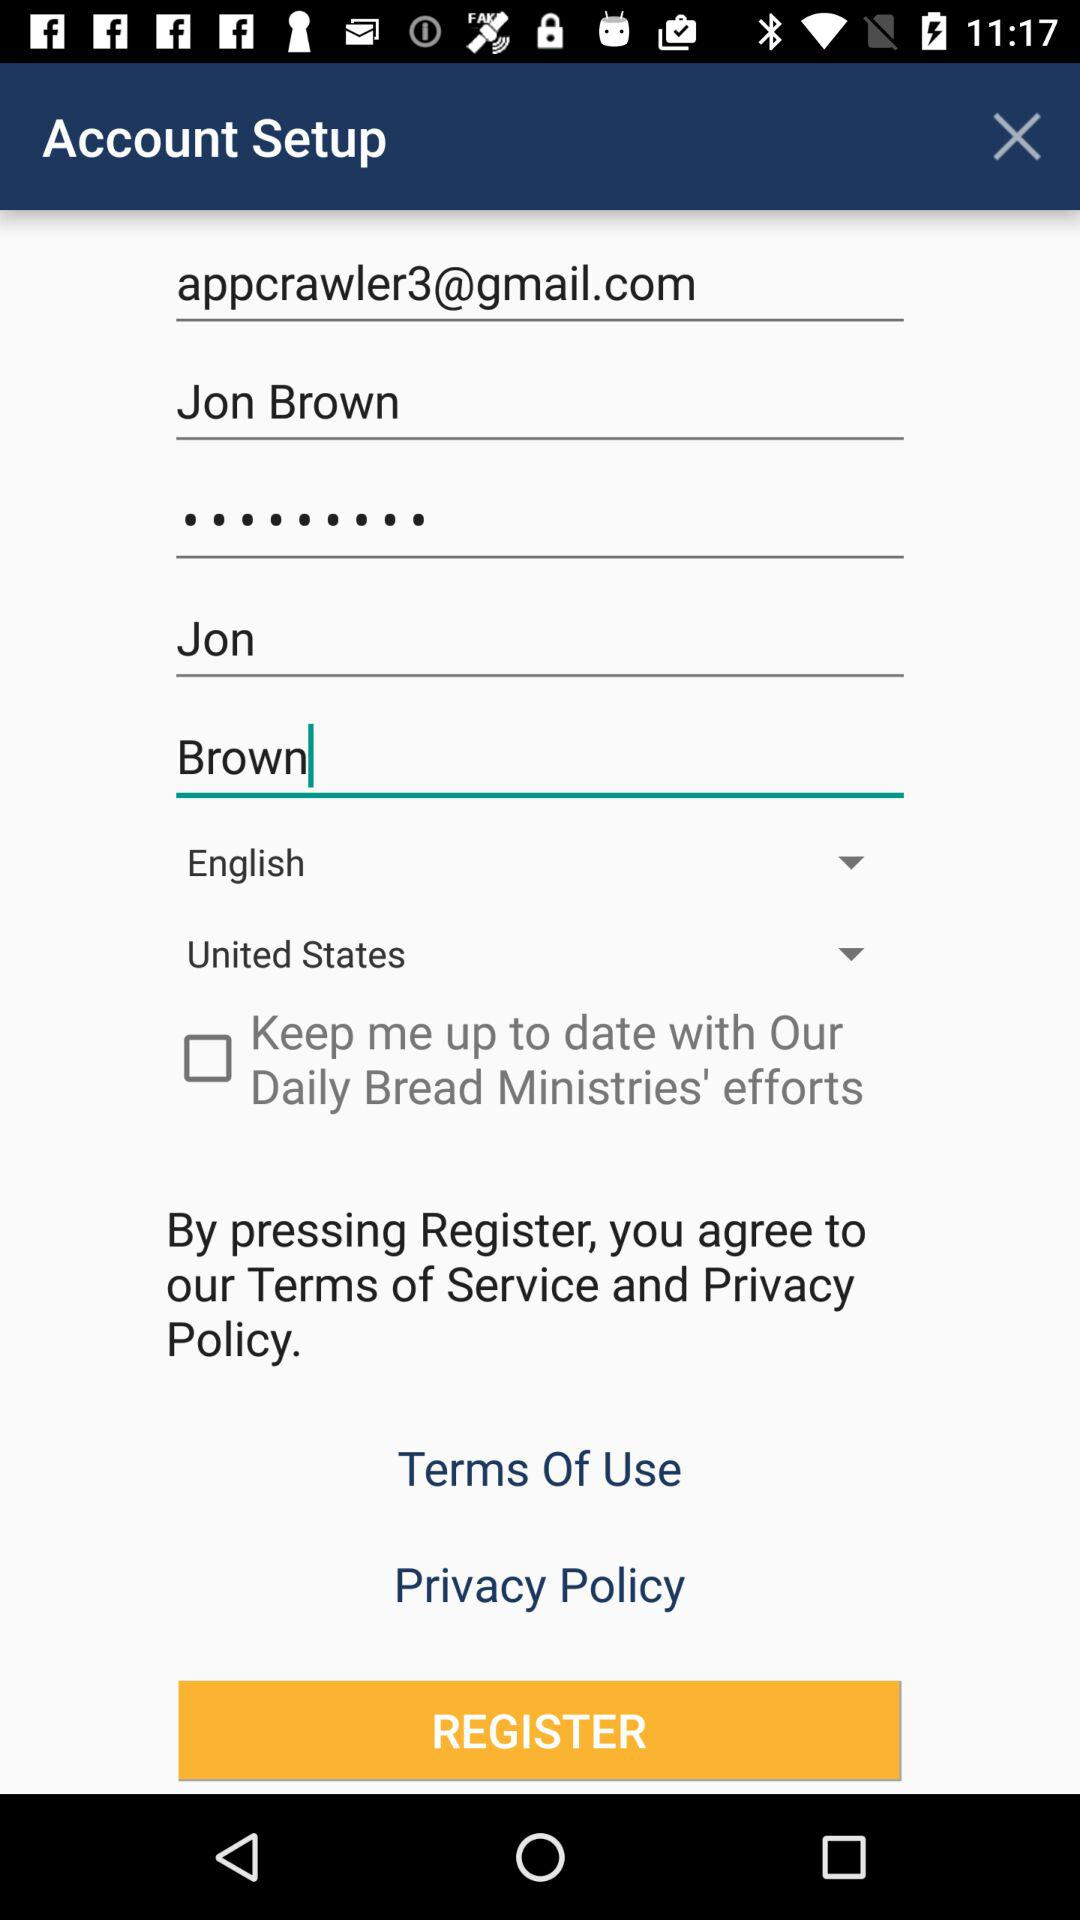Which country does John belong to? John belongs to the United States. 